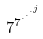Convert formula to latex. <formula><loc_0><loc_0><loc_500><loc_500>7 ^ { 7 ^ { \cdot ^ { \cdot ^ { \cdot ^ { j } } } } }</formula> 